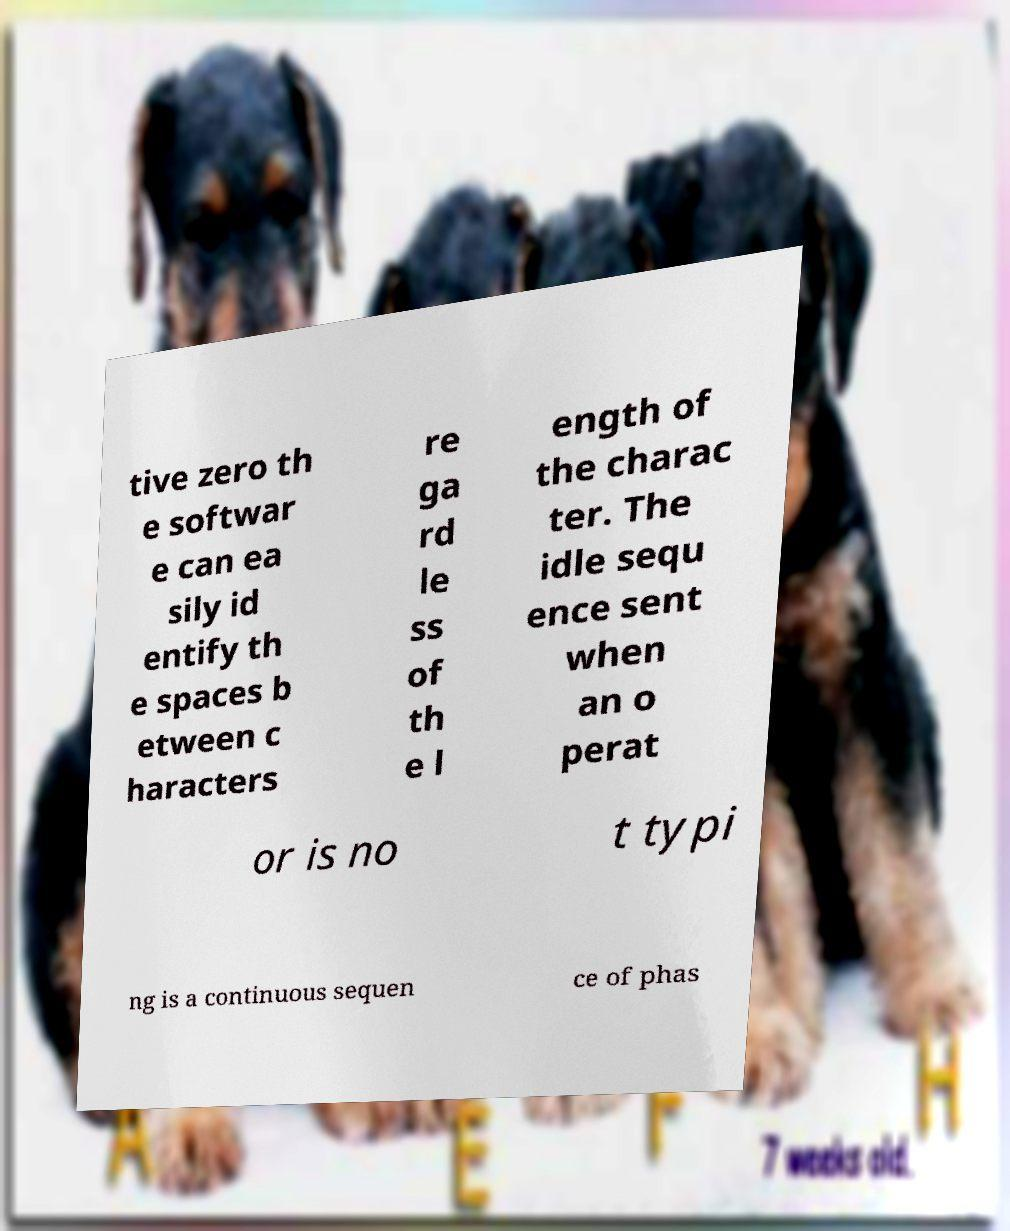What messages or text are displayed in this image? I need them in a readable, typed format. tive zero th e softwar e can ea sily id entify th e spaces b etween c haracters re ga rd le ss of th e l ength of the charac ter. The idle sequ ence sent when an o perat or is no t typi ng is a continuous sequen ce of phas 